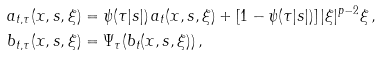Convert formula to latex. <formula><loc_0><loc_0><loc_500><loc_500>& a _ { t , \tau } ( x , s , \xi ) = \psi ( \tau | s | ) \, a _ { t } ( x , s , \xi ) + [ 1 - \psi ( \tau | s | ) ] \, | \xi | ^ { p - 2 } \xi \, , \\ & b _ { t , \tau } ( x , s , \xi ) = \Psi _ { \tau } ( b _ { t } ( x , s , \xi ) ) \, ,</formula> 